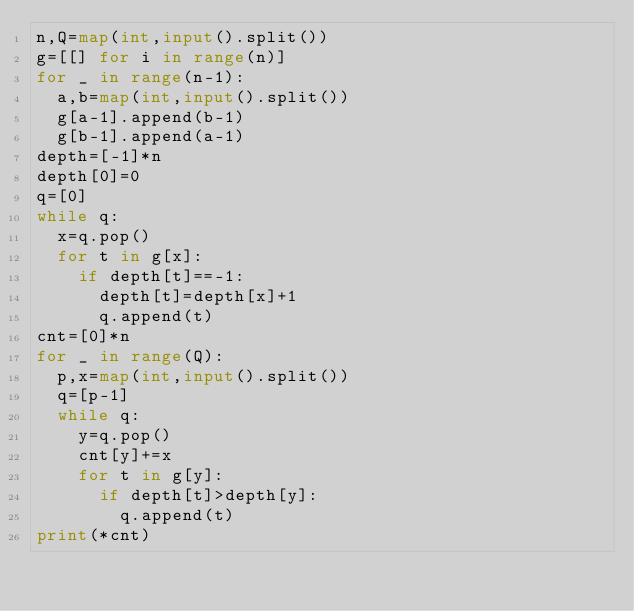<code> <loc_0><loc_0><loc_500><loc_500><_Python_>n,Q=map(int,input().split())
g=[[] for i in range(n)]
for _ in range(n-1):
  a,b=map(int,input().split())
  g[a-1].append(b-1)
  g[b-1].append(a-1)
depth=[-1]*n
depth[0]=0
q=[0]
while q:
  x=q.pop()
  for t in g[x]:
    if depth[t]==-1:
      depth[t]=depth[x]+1
      q.append(t)
cnt=[0]*n
for _ in range(Q):
  p,x=map(int,input().split())
  q=[p-1]
  while q:
    y=q.pop()
    cnt[y]+=x
    for t in g[y]:
      if depth[t]>depth[y]:
        q.append(t)
print(*cnt)</code> 